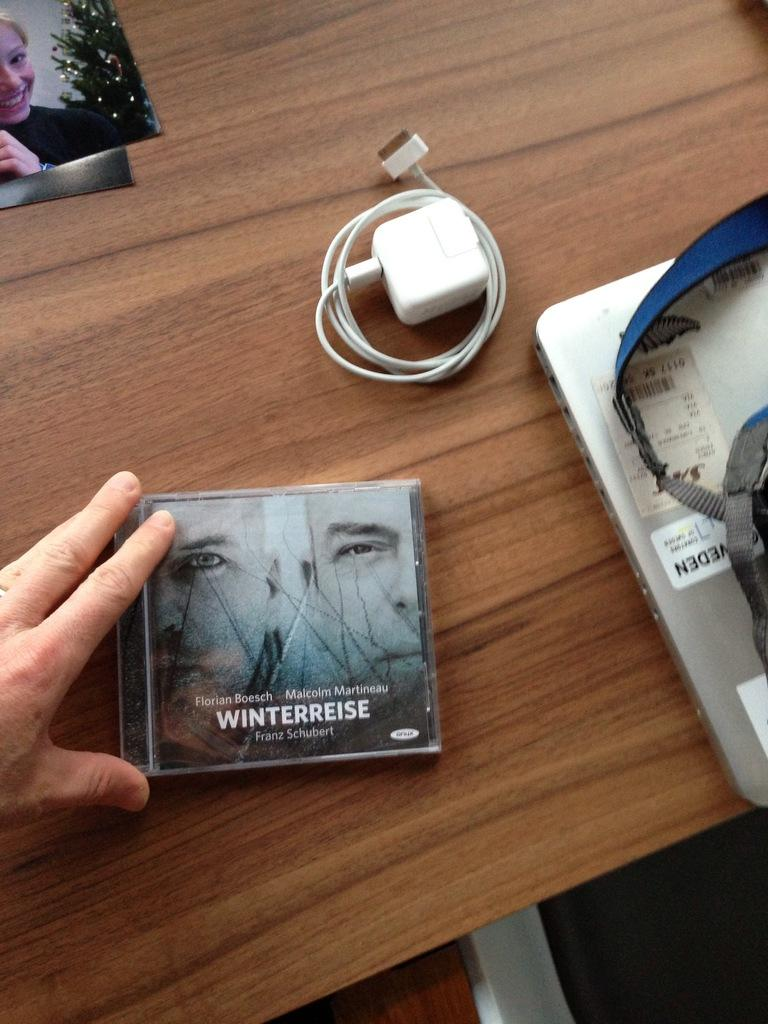<image>
Offer a succinct explanation of the picture presented. cd fronm winterreise and iphone charger on the table 